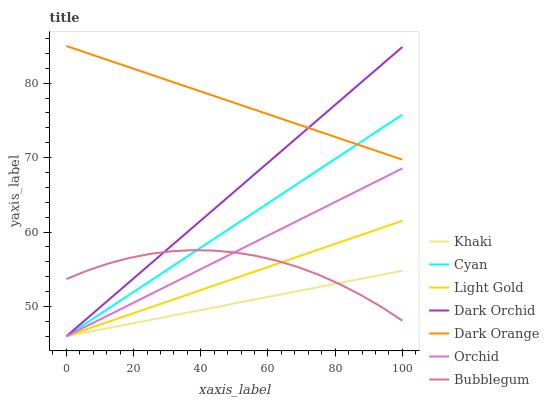Does Khaki have the minimum area under the curve?
Answer yes or no. Yes. Does Dark Orange have the maximum area under the curve?
Answer yes or no. Yes. Does Dark Orchid have the minimum area under the curve?
Answer yes or no. No. Does Dark Orchid have the maximum area under the curve?
Answer yes or no. No. Is Dark Orchid the smoothest?
Answer yes or no. Yes. Is Bubblegum the roughest?
Answer yes or no. Yes. Is Khaki the smoothest?
Answer yes or no. No. Is Khaki the roughest?
Answer yes or no. No. Does Khaki have the lowest value?
Answer yes or no. Yes. Does Bubblegum have the lowest value?
Answer yes or no. No. Does Dark Orange have the highest value?
Answer yes or no. Yes. Does Dark Orchid have the highest value?
Answer yes or no. No. Is Light Gold less than Dark Orange?
Answer yes or no. Yes. Is Dark Orange greater than Bubblegum?
Answer yes or no. Yes. Does Cyan intersect Light Gold?
Answer yes or no. Yes. Is Cyan less than Light Gold?
Answer yes or no. No. Is Cyan greater than Light Gold?
Answer yes or no. No. Does Light Gold intersect Dark Orange?
Answer yes or no. No. 